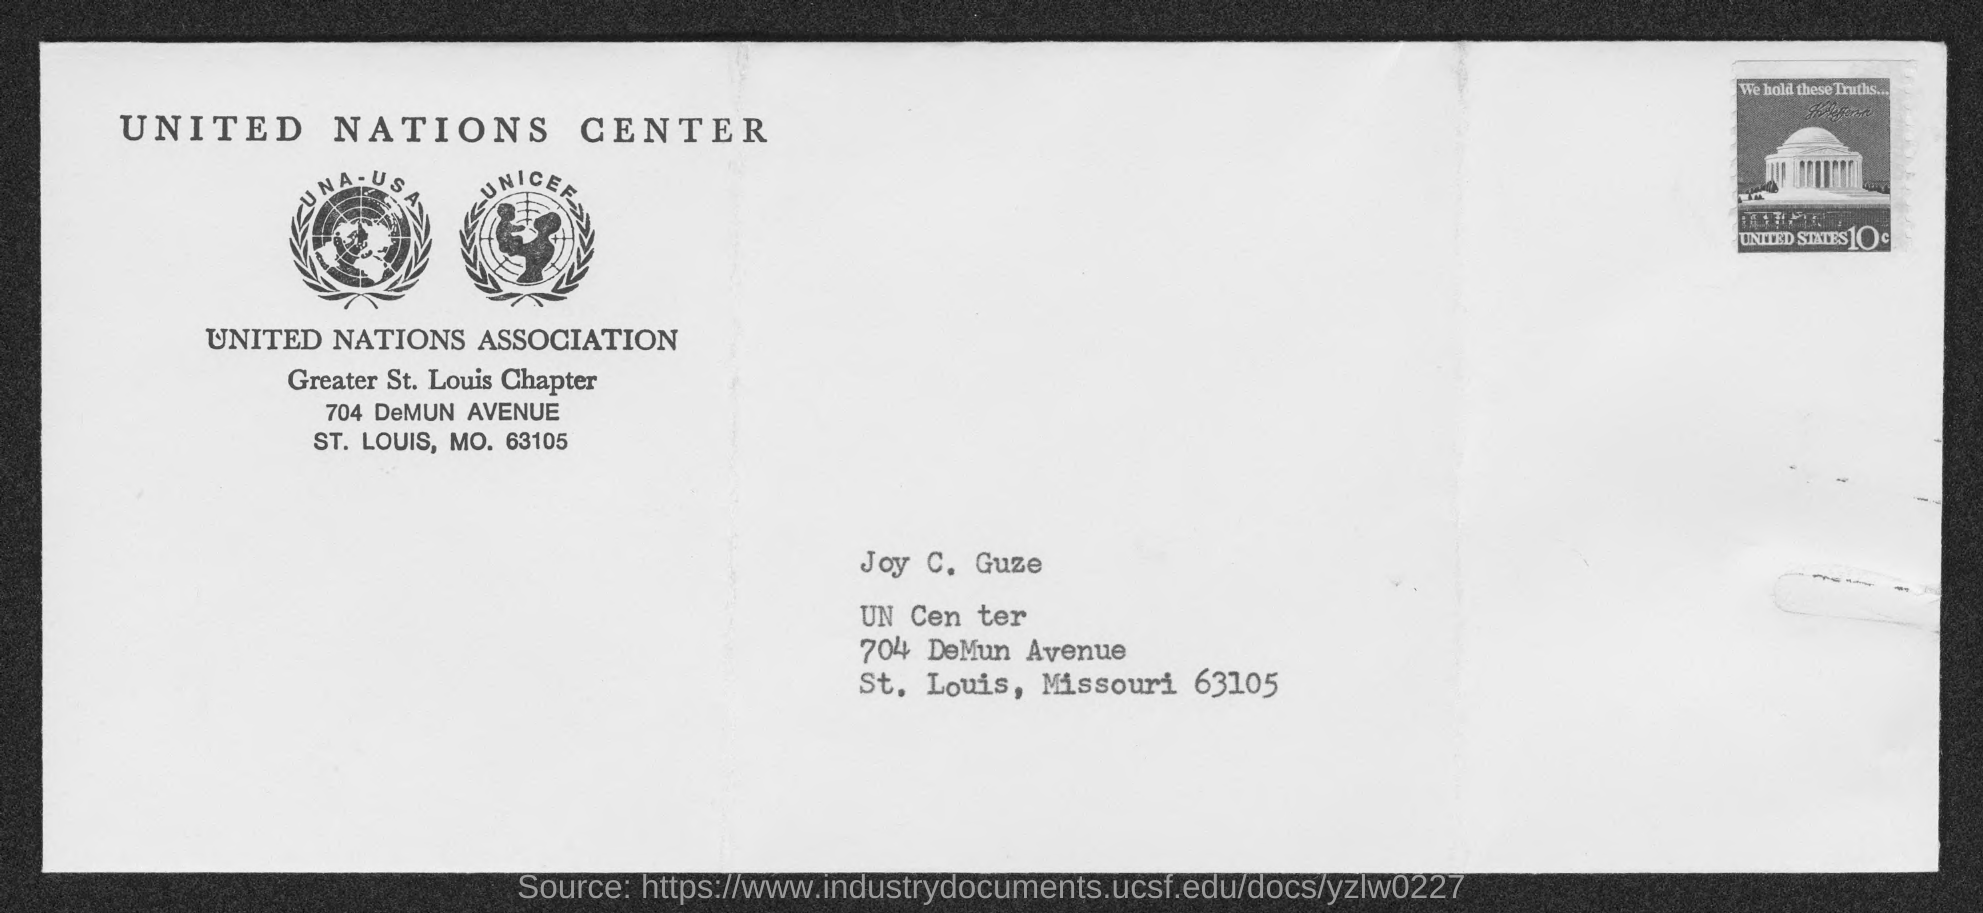What is the name of the person mentioned in the address?
Offer a terse response. Joy C. Guze. 